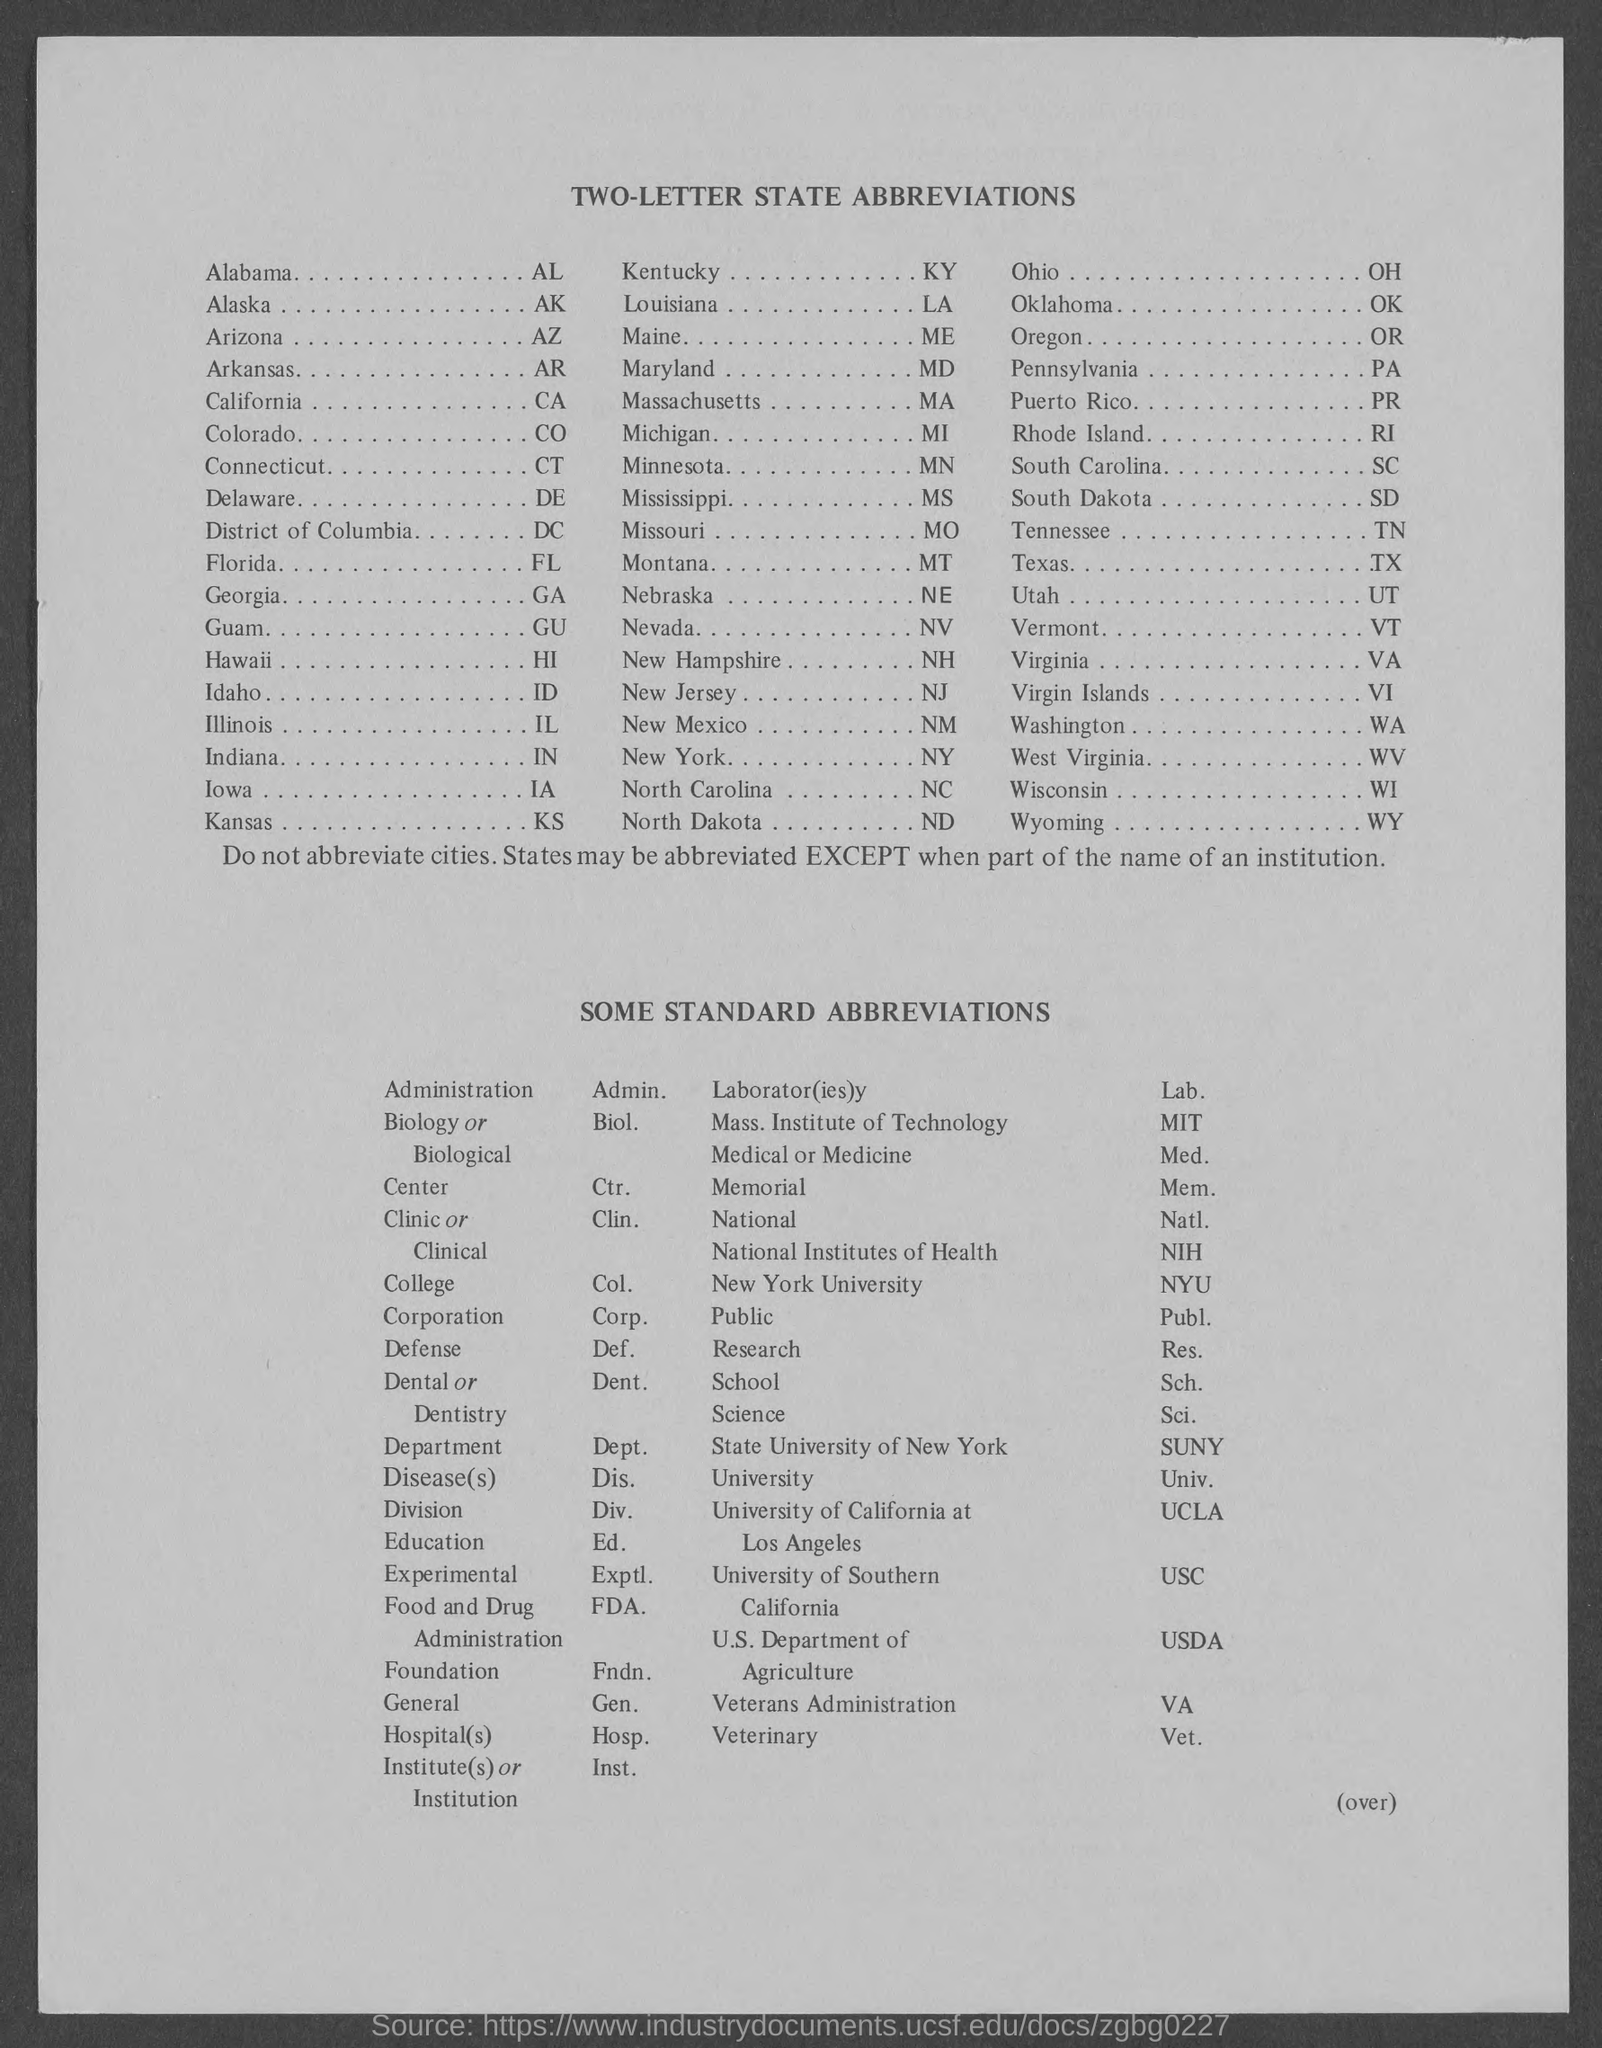What is the abbreviation for Administration?
Make the answer very short. Admin. What is the abbreviation for New York University?
Your response must be concise. NYU. What is the abbreviation for Alaska?
Offer a terse response. AK. What is the fullform of NIH?
Offer a terse response. National Institutes of Health. What is the fullform of FDA?
Offer a very short reply. Food and Drug Administration. 